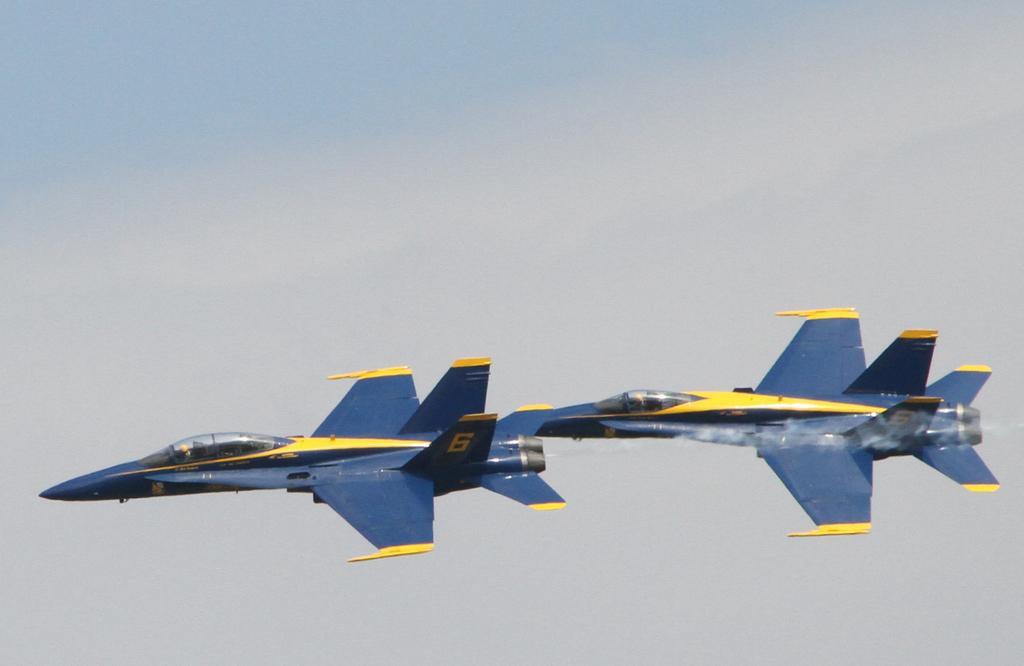<image>
Give a short and clear explanation of the subsequent image. Two jet aircraft in flight have the number 5 and the number 6 on their tails. 